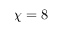<formula> <loc_0><loc_0><loc_500><loc_500>\chi = 8</formula> 